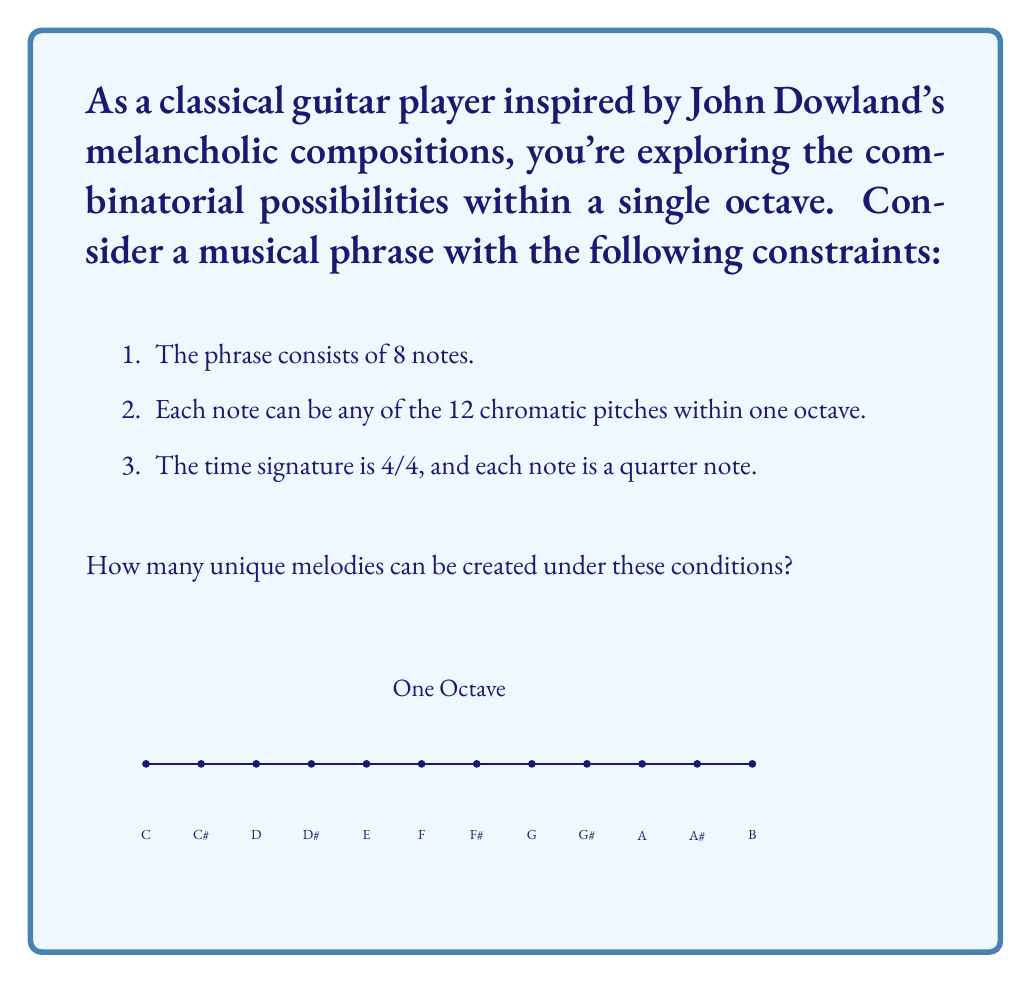Give your solution to this math problem. Let's approach this step-by-step:

1) We have 8 note positions in our melody (4/4 time signature with 8 quarter notes).

2) For each position, we can choose any of the 12 chromatic pitches within the octave.

3) This scenario represents a classic case of the multiplication principle in combinatorics. We're making 8 independent choices, each with 12 options.

4) The total number of possible melodies is therefore:

   $$12 \times 12 \times 12 \times 12 \times 12 \times 12 \times 12 \times 12$$

5) This can be written more concisely as an exponent:

   $$12^8$$

6) To calculate this:
   $$12^8 = 429,981,696$$

This large number reflects the vast possibilities available even within a single octave, reminiscent of how John Dowland could create such varied and emotionally rich compositions within the constraints of Renaissance music.
Answer: $12^8 = 429,981,696$ 